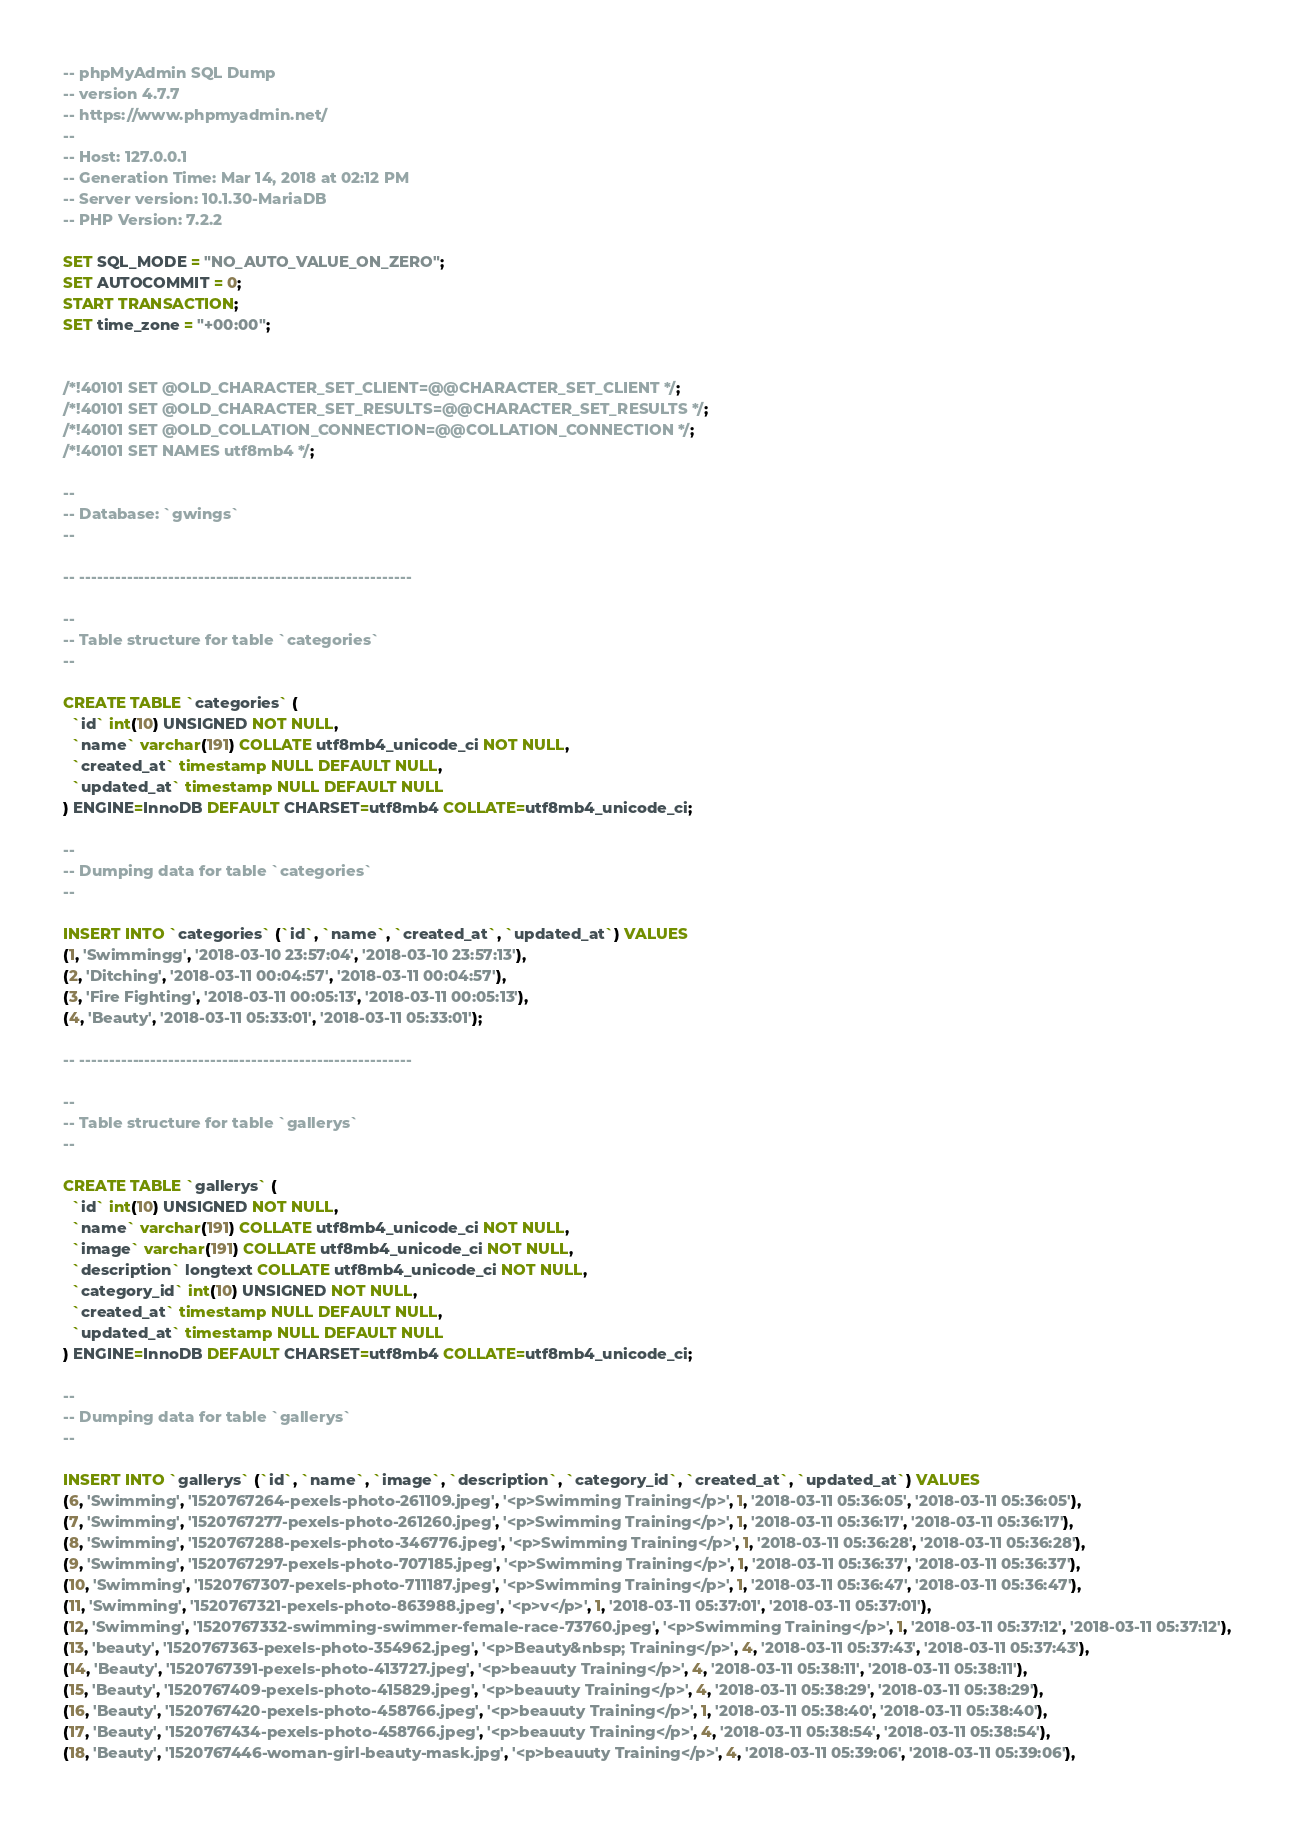<code> <loc_0><loc_0><loc_500><loc_500><_SQL_>-- phpMyAdmin SQL Dump
-- version 4.7.7
-- https://www.phpmyadmin.net/
--
-- Host: 127.0.0.1
-- Generation Time: Mar 14, 2018 at 02:12 PM
-- Server version: 10.1.30-MariaDB
-- PHP Version: 7.2.2

SET SQL_MODE = "NO_AUTO_VALUE_ON_ZERO";
SET AUTOCOMMIT = 0;
START TRANSACTION;
SET time_zone = "+00:00";


/*!40101 SET @OLD_CHARACTER_SET_CLIENT=@@CHARACTER_SET_CLIENT */;
/*!40101 SET @OLD_CHARACTER_SET_RESULTS=@@CHARACTER_SET_RESULTS */;
/*!40101 SET @OLD_COLLATION_CONNECTION=@@COLLATION_CONNECTION */;
/*!40101 SET NAMES utf8mb4 */;

--
-- Database: `gwings`
--

-- --------------------------------------------------------

--
-- Table structure for table `categories`
--

CREATE TABLE `categories` (
  `id` int(10) UNSIGNED NOT NULL,
  `name` varchar(191) COLLATE utf8mb4_unicode_ci NOT NULL,
  `created_at` timestamp NULL DEFAULT NULL,
  `updated_at` timestamp NULL DEFAULT NULL
) ENGINE=InnoDB DEFAULT CHARSET=utf8mb4 COLLATE=utf8mb4_unicode_ci;

--
-- Dumping data for table `categories`
--

INSERT INTO `categories` (`id`, `name`, `created_at`, `updated_at`) VALUES
(1, 'Swimmingg', '2018-03-10 23:57:04', '2018-03-10 23:57:13'),
(2, 'Ditching', '2018-03-11 00:04:57', '2018-03-11 00:04:57'),
(3, 'Fire Fighting', '2018-03-11 00:05:13', '2018-03-11 00:05:13'),
(4, 'Beauty', '2018-03-11 05:33:01', '2018-03-11 05:33:01');

-- --------------------------------------------------------

--
-- Table structure for table `gallerys`
--

CREATE TABLE `gallerys` (
  `id` int(10) UNSIGNED NOT NULL,
  `name` varchar(191) COLLATE utf8mb4_unicode_ci NOT NULL,
  `image` varchar(191) COLLATE utf8mb4_unicode_ci NOT NULL,
  `description` longtext COLLATE utf8mb4_unicode_ci NOT NULL,
  `category_id` int(10) UNSIGNED NOT NULL,
  `created_at` timestamp NULL DEFAULT NULL,
  `updated_at` timestamp NULL DEFAULT NULL
) ENGINE=InnoDB DEFAULT CHARSET=utf8mb4 COLLATE=utf8mb4_unicode_ci;

--
-- Dumping data for table `gallerys`
--

INSERT INTO `gallerys` (`id`, `name`, `image`, `description`, `category_id`, `created_at`, `updated_at`) VALUES
(6, 'Swimming', '1520767264-pexels-photo-261109.jpeg', '<p>Swimming Training</p>', 1, '2018-03-11 05:36:05', '2018-03-11 05:36:05'),
(7, 'Swimming', '1520767277-pexels-photo-261260.jpeg', '<p>Swimming Training</p>', 1, '2018-03-11 05:36:17', '2018-03-11 05:36:17'),
(8, 'Swimming', '1520767288-pexels-photo-346776.jpeg', '<p>Swimming Training</p>', 1, '2018-03-11 05:36:28', '2018-03-11 05:36:28'),
(9, 'Swimming', '1520767297-pexels-photo-707185.jpeg', '<p>Swimming Training</p>', 1, '2018-03-11 05:36:37', '2018-03-11 05:36:37'),
(10, 'Swimming', '1520767307-pexels-photo-711187.jpeg', '<p>Swimming Training</p>', 1, '2018-03-11 05:36:47', '2018-03-11 05:36:47'),
(11, 'Swimming', '1520767321-pexels-photo-863988.jpeg', '<p>v</p>', 1, '2018-03-11 05:37:01', '2018-03-11 05:37:01'),
(12, 'Swimming', '1520767332-swimming-swimmer-female-race-73760.jpeg', '<p>Swimming Training</p>', 1, '2018-03-11 05:37:12', '2018-03-11 05:37:12'),
(13, 'beauty', '1520767363-pexels-photo-354962.jpeg', '<p>Beauty&nbsp; Training</p>', 4, '2018-03-11 05:37:43', '2018-03-11 05:37:43'),
(14, 'Beauty', '1520767391-pexels-photo-413727.jpeg', '<p>beauuty Training</p>', 4, '2018-03-11 05:38:11', '2018-03-11 05:38:11'),
(15, 'Beauty', '1520767409-pexels-photo-415829.jpeg', '<p>beauuty Training</p>', 4, '2018-03-11 05:38:29', '2018-03-11 05:38:29'),
(16, 'Beauty', '1520767420-pexels-photo-458766.jpeg', '<p>beauuty Training</p>', 1, '2018-03-11 05:38:40', '2018-03-11 05:38:40'),
(17, 'Beauty', '1520767434-pexels-photo-458766.jpeg', '<p>beauuty Training</p>', 4, '2018-03-11 05:38:54', '2018-03-11 05:38:54'),
(18, 'Beauty', '1520767446-woman-girl-beauty-mask.jpg', '<p>beauuty Training</p>', 4, '2018-03-11 05:39:06', '2018-03-11 05:39:06'),</code> 